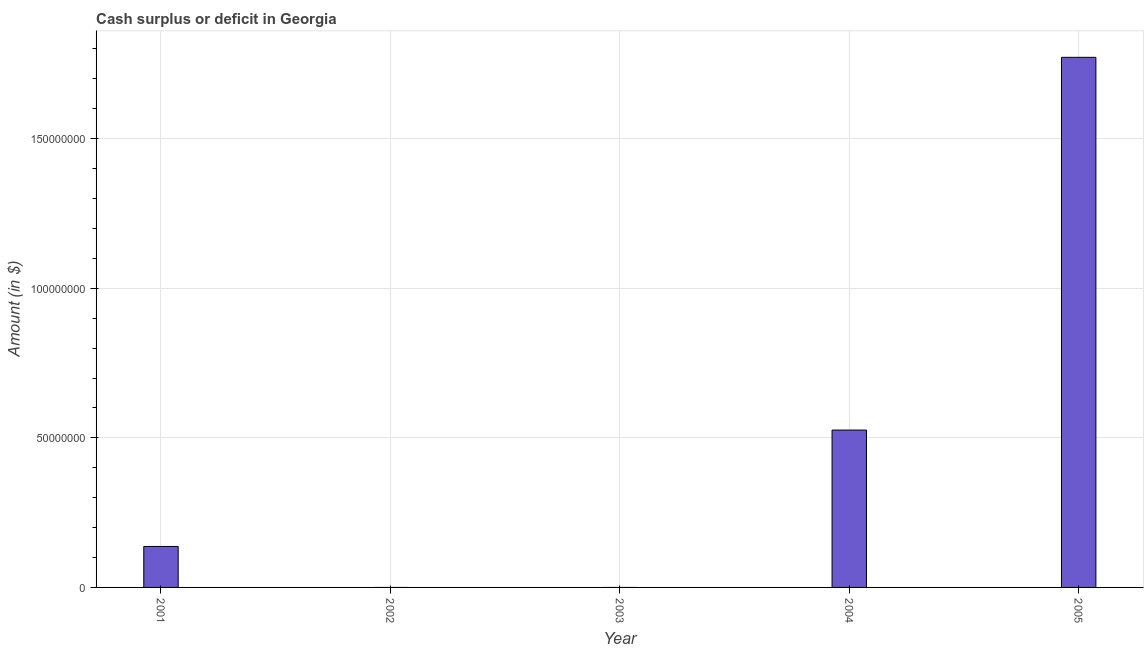Does the graph contain any zero values?
Your answer should be very brief. Yes. What is the title of the graph?
Your response must be concise. Cash surplus or deficit in Georgia. What is the label or title of the Y-axis?
Provide a short and direct response. Amount (in $). What is the cash surplus or deficit in 2002?
Offer a terse response. 0. Across all years, what is the maximum cash surplus or deficit?
Your answer should be compact. 1.77e+08. In which year was the cash surplus or deficit maximum?
Keep it short and to the point. 2005. What is the sum of the cash surplus or deficit?
Give a very brief answer. 2.44e+08. What is the difference between the cash surplus or deficit in 2001 and 2004?
Provide a succinct answer. -3.89e+07. What is the average cash surplus or deficit per year?
Ensure brevity in your answer.  4.87e+07. What is the median cash surplus or deficit?
Offer a terse response. 1.37e+07. What is the ratio of the cash surplus or deficit in 2001 to that in 2004?
Offer a very short reply. 0.26. Is the cash surplus or deficit in 2001 less than that in 2005?
Ensure brevity in your answer.  Yes. Is the difference between the cash surplus or deficit in 2001 and 2004 greater than the difference between any two years?
Your answer should be very brief. No. What is the difference between the highest and the second highest cash surplus or deficit?
Keep it short and to the point. 1.25e+08. Is the sum of the cash surplus or deficit in 2004 and 2005 greater than the maximum cash surplus or deficit across all years?
Keep it short and to the point. Yes. What is the difference between the highest and the lowest cash surplus or deficit?
Offer a very short reply. 1.77e+08. How many bars are there?
Your answer should be very brief. 3. Are all the bars in the graph horizontal?
Provide a short and direct response. No. How many years are there in the graph?
Provide a succinct answer. 5. What is the difference between two consecutive major ticks on the Y-axis?
Ensure brevity in your answer.  5.00e+07. Are the values on the major ticks of Y-axis written in scientific E-notation?
Keep it short and to the point. No. What is the Amount (in $) in 2001?
Your response must be concise. 1.37e+07. What is the Amount (in $) of 2002?
Your answer should be very brief. 0. What is the Amount (in $) in 2003?
Provide a succinct answer. 0. What is the Amount (in $) in 2004?
Give a very brief answer. 5.26e+07. What is the Amount (in $) in 2005?
Provide a succinct answer. 1.77e+08. What is the difference between the Amount (in $) in 2001 and 2004?
Offer a terse response. -3.89e+07. What is the difference between the Amount (in $) in 2001 and 2005?
Your answer should be very brief. -1.64e+08. What is the difference between the Amount (in $) in 2004 and 2005?
Offer a terse response. -1.25e+08. What is the ratio of the Amount (in $) in 2001 to that in 2004?
Provide a succinct answer. 0.26. What is the ratio of the Amount (in $) in 2001 to that in 2005?
Give a very brief answer. 0.08. What is the ratio of the Amount (in $) in 2004 to that in 2005?
Ensure brevity in your answer.  0.3. 